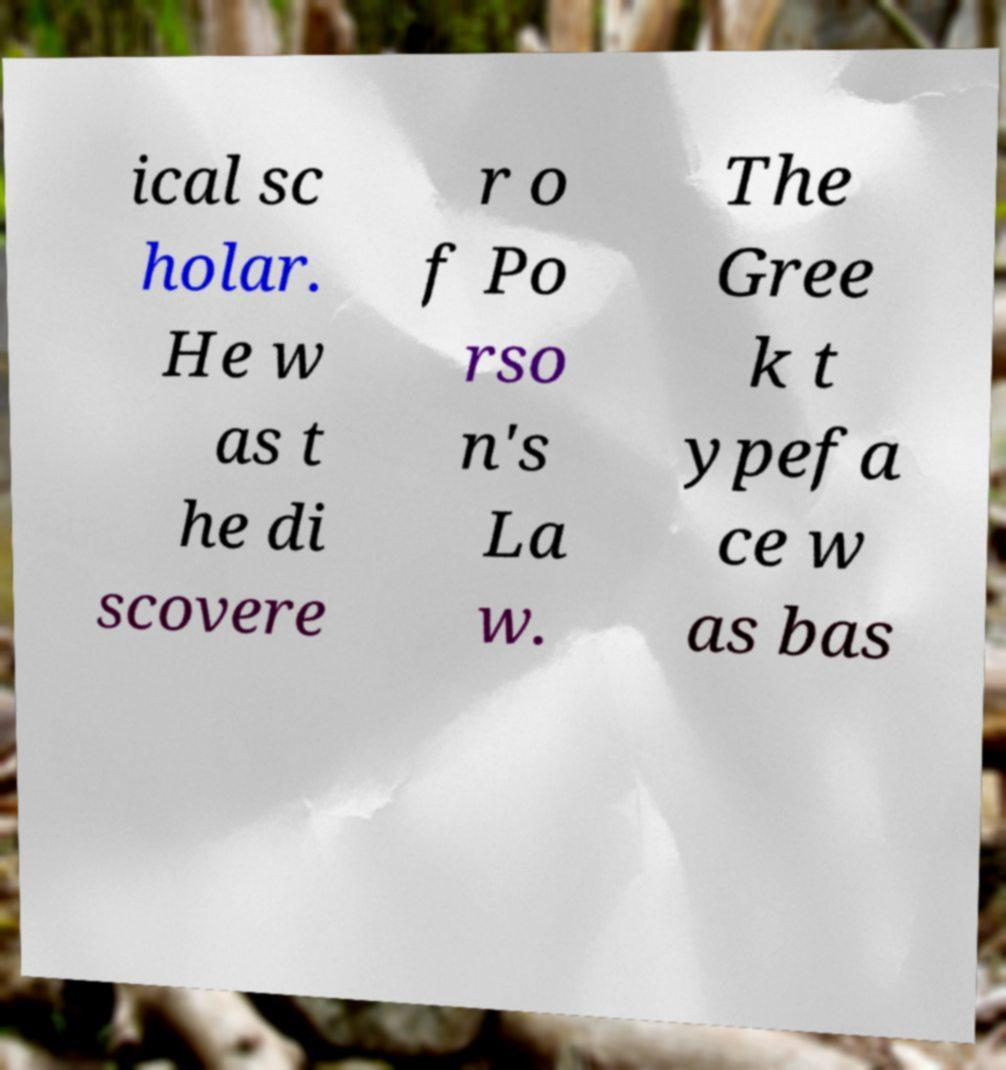Please read and relay the text visible in this image. What does it say? ical sc holar. He w as t he di scovere r o f Po rso n's La w. The Gree k t ypefa ce w as bas 